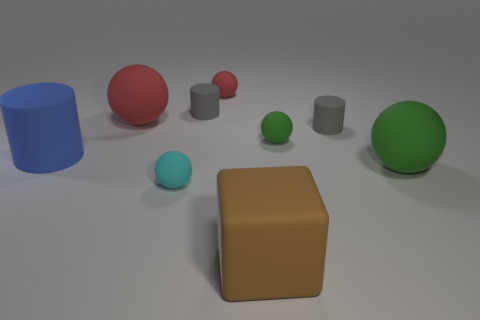Subtract all green balls. How many balls are left? 3 Subtract all small cylinders. How many cylinders are left? 1 Subtract all purple spheres. Subtract all blue cubes. How many spheres are left? 5 Subtract all spheres. How many objects are left? 4 Add 6 tiny matte cylinders. How many tiny matte cylinders are left? 8 Add 4 gray matte things. How many gray matte things exist? 6 Subtract 0 purple blocks. How many objects are left? 9 Subtract all big blue rubber cylinders. Subtract all small red metal objects. How many objects are left? 8 